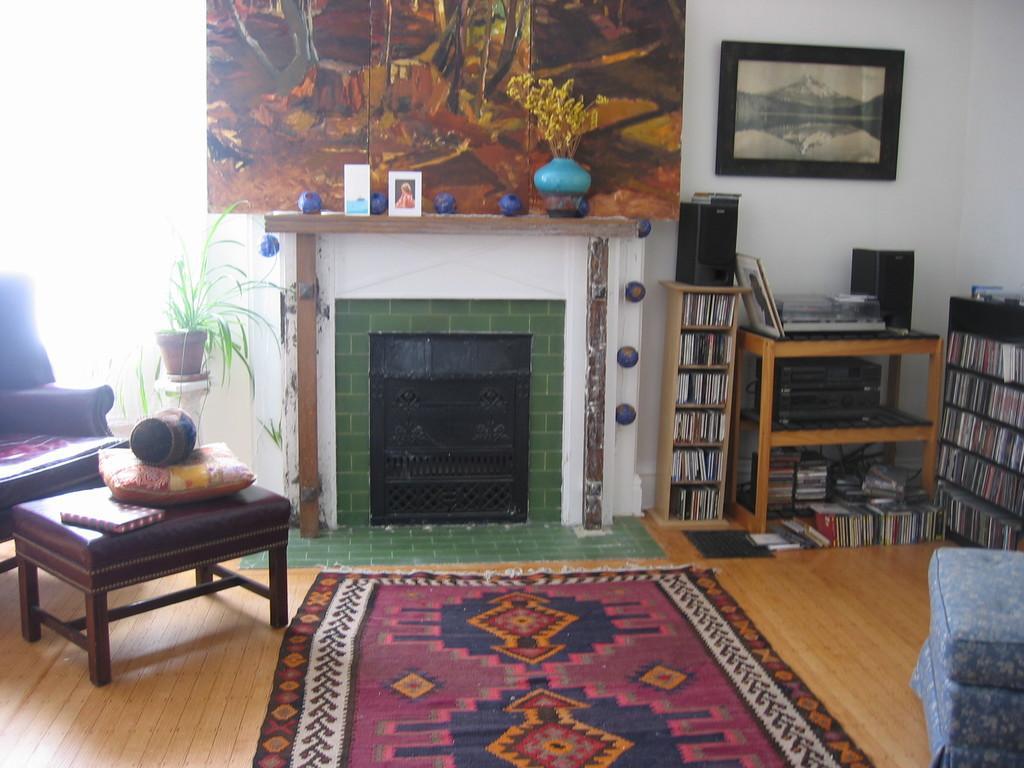Please provide a concise description of this image. The image is inside the room. In the image we can see on left side plants,flower pot,couch,table. On table there are pillow,book. On right side there is a shelf with some books,wall,frame. On bottom there is a mat, in middle there is a painting,flower pot,frame. 